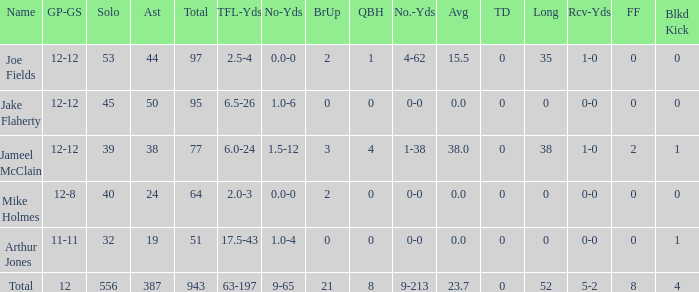What is the entire brup for the squad? 21.0. Could you parse the entire table as a dict? {'header': ['Name', 'GP-GS', 'Solo', 'Ast', 'Total', 'TFL-Yds', 'No-Yds', 'BrUp', 'QBH', 'No.-Yds', 'Avg', 'TD', 'Long', 'Rcv-Yds', 'FF', 'Blkd Kick'], 'rows': [['Joe Fields', '12-12', '53', '44', '97', '2.5-4', '0.0-0', '2', '1', '4-62', '15.5', '0', '35', '1-0', '0', '0'], ['Jake Flaherty', '12-12', '45', '50', '95', '6.5-26', '1.0-6', '0', '0', '0-0', '0.0', '0', '0', '0-0', '0', '0'], ['Jameel McClain', '12-12', '39', '38', '77', '6.0-24', '1.5-12', '3', '4', '1-38', '38.0', '0', '38', '1-0', '2', '1'], ['Mike Holmes', '12-8', '40', '24', '64', '2.0-3', '0.0-0', '2', '0', '0-0', '0.0', '0', '0', '0-0', '0', '0'], ['Arthur Jones', '11-11', '32', '19', '51', '17.5-43', '1.0-4', '0', '0', '0-0', '0.0', '0', '0', '0-0', '0', '1'], ['Total', '12', '556', '387', '943', '63-197', '9-65', '21', '8', '9-213', '23.7', '0', '52', '5-2', '8', '4']]} 